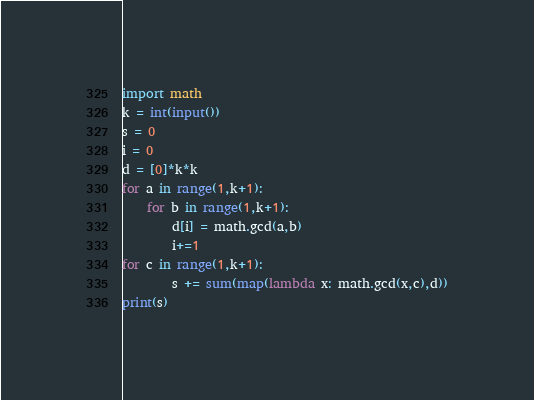Convert code to text. <code><loc_0><loc_0><loc_500><loc_500><_Python_>import math
k = int(input())
s = 0
i = 0
d = [0]*k*k
for a in range(1,k+1):
    for b in range(1,k+1):
        d[i] = math.gcd(a,b)
        i+=1
for c in range(1,k+1):
        s += sum(map(lambda x: math.gcd(x,c),d))
print(s)</code> 